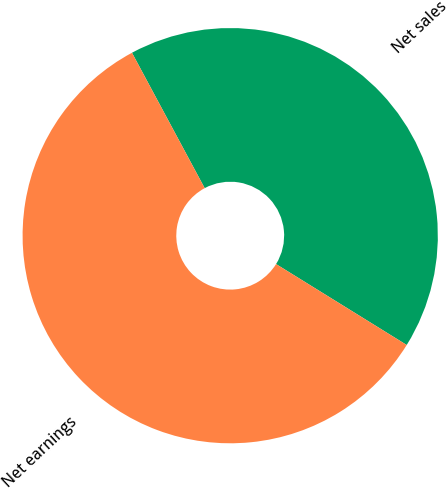Convert chart to OTSL. <chart><loc_0><loc_0><loc_500><loc_500><pie_chart><fcel>Net sales<fcel>Net earnings<nl><fcel>41.67%<fcel>58.33%<nl></chart> 